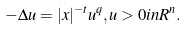<formula> <loc_0><loc_0><loc_500><loc_500>- \Delta u = | x | ^ { - t } u ^ { q } , u > 0 i n R ^ { n } .</formula> 